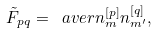<formula> <loc_0><loc_0><loc_500><loc_500>\tilde { F } _ { p q } = \ a v e r { n ^ { [ p ] } _ { m } { n } ^ { [ q ] } _ { m ^ { \prime } } } ,</formula> 